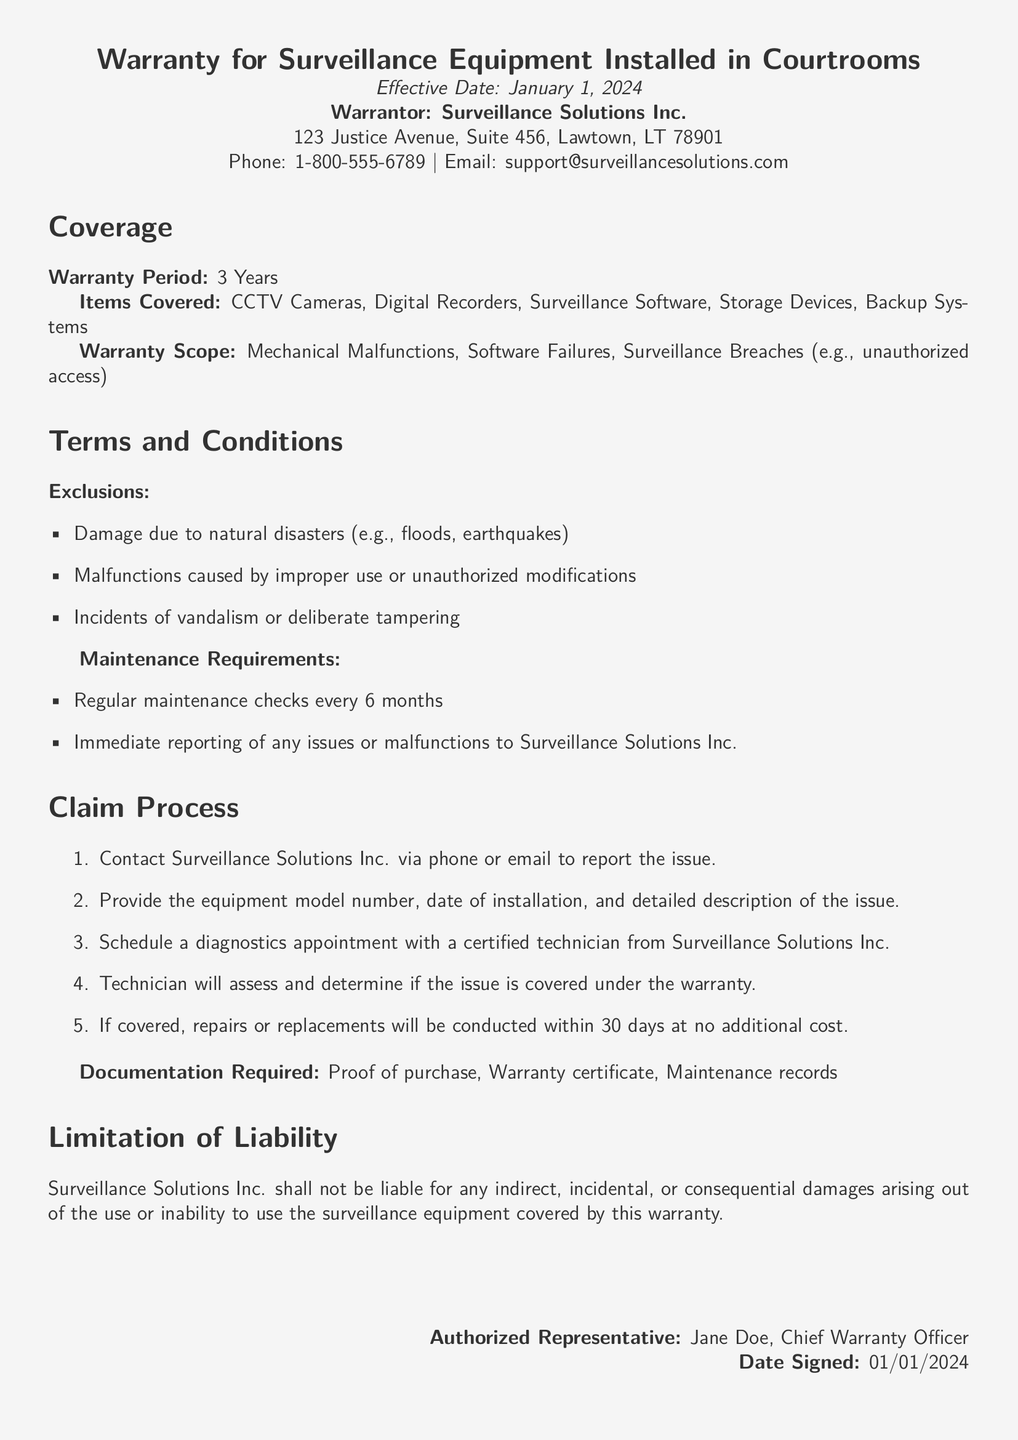what is the effective date of the warranty? The effective date of the warranty is stated at the beginning of the document.
Answer: January 1, 2024 who is the warrantor? The document specifies the entity providing the warranty in the introduction.
Answer: Surveillance Solutions Inc what is the duration of the warranty period? The warranty period is mentioned under the coverage section of the document.
Answer: 3 Years which types of damages are excluded from the warranty? The exclusions are listed in the terms and conditions section of the document.
Answer: Natural disasters, improper use, vandalism how often are maintenance checks required? The maintenance requirements specify how frequently checks should be conducted.
Answer: Every 6 months what is the first step in the claim process? The claim process outlines specific steps that need to be taken to report an issue.
Answer: Contact Surveillance Solutions Inc how long will repairs take if the issue is covered? The document indicates the timeframe for repairs once an issue is confirmed as covered.
Answer: 30 days who is the authorized representative? The authorized representative is mentioned at the end of the document.
Answer: Jane Doe what must be provided as documentation when claiming? The required documentation is listed under the claim process section.
Answer: Proof of purchase, Warranty certificate, Maintenance records 